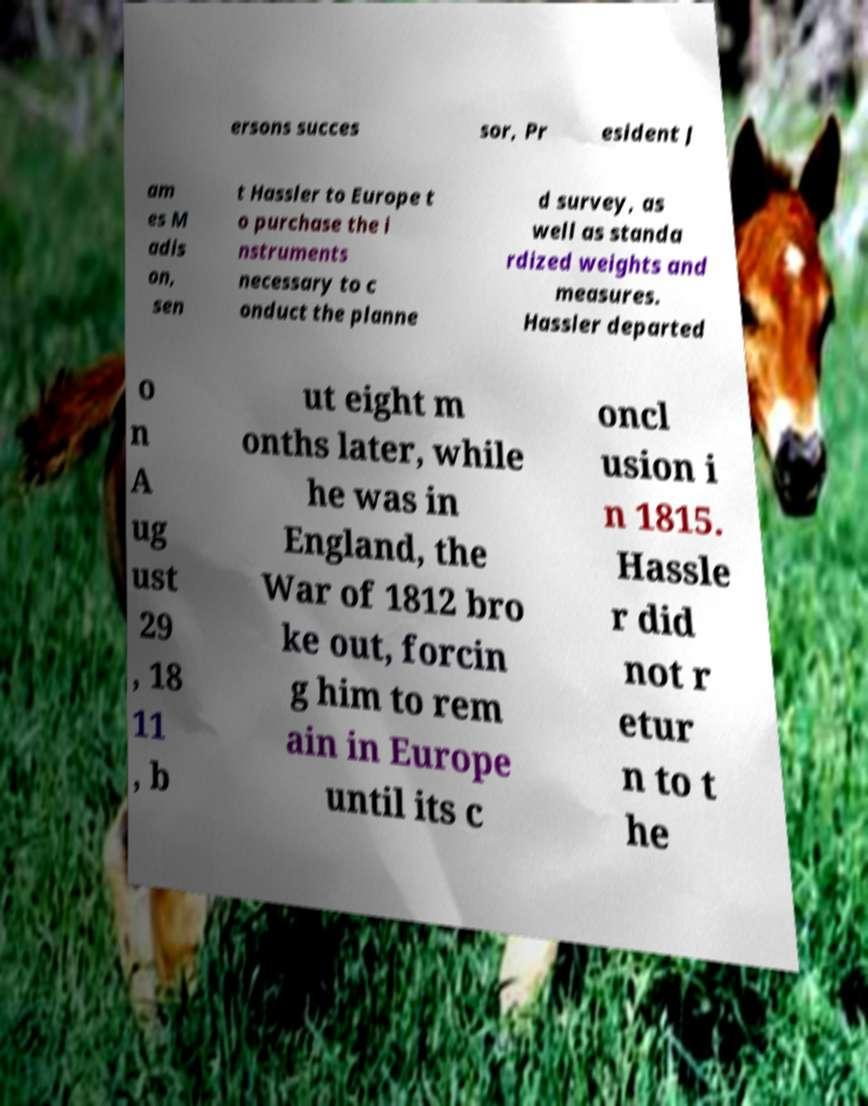There's text embedded in this image that I need extracted. Can you transcribe it verbatim? ersons succes sor, Pr esident J am es M adis on, sen t Hassler to Europe t o purchase the i nstruments necessary to c onduct the planne d survey, as well as standa rdized weights and measures. Hassler departed o n A ug ust 29 , 18 11 , b ut eight m onths later, while he was in England, the War of 1812 bro ke out, forcin g him to rem ain in Europe until its c oncl usion i n 1815. Hassle r did not r etur n to t he 